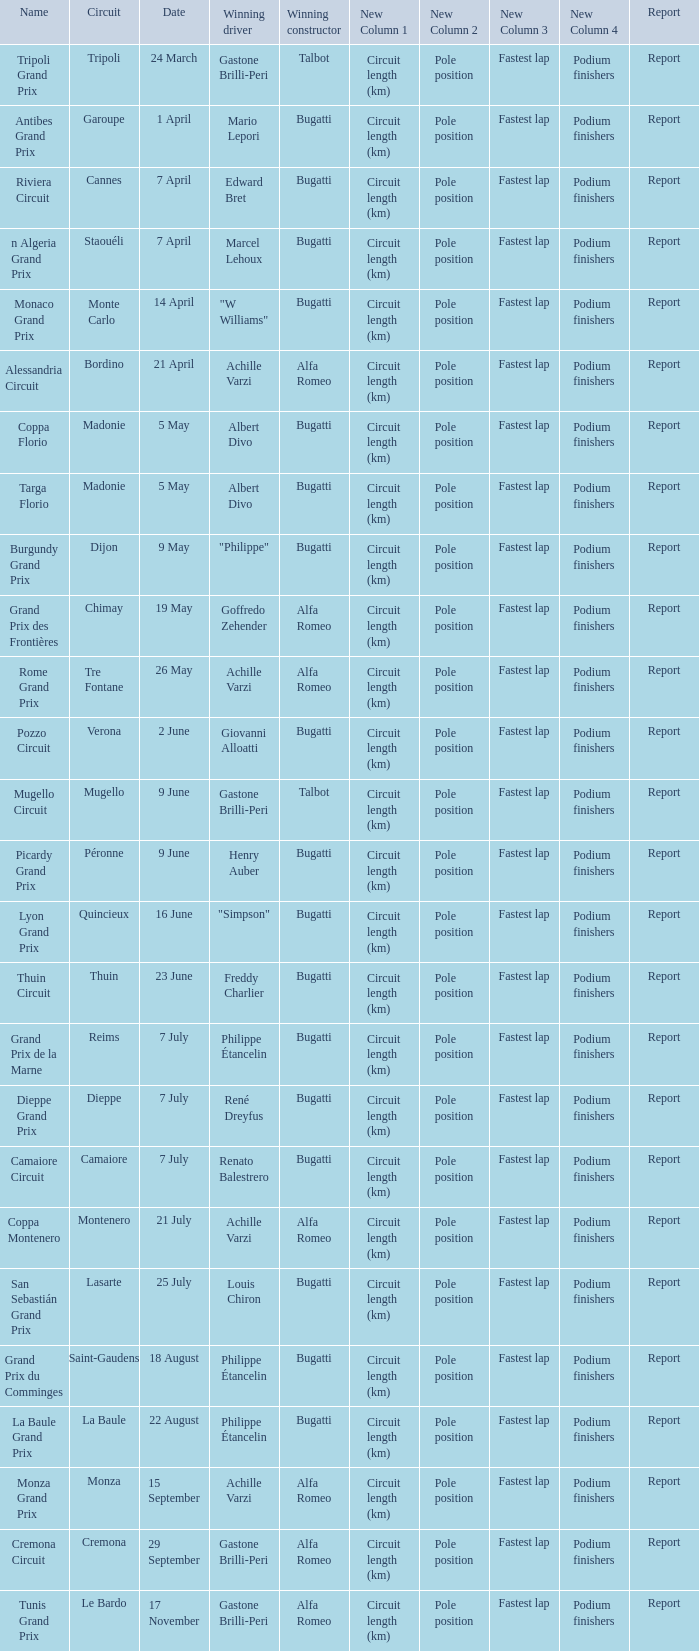What Circuit has a Winning constructor of bugatti, and a Winning driver of edward bret? Cannes. 